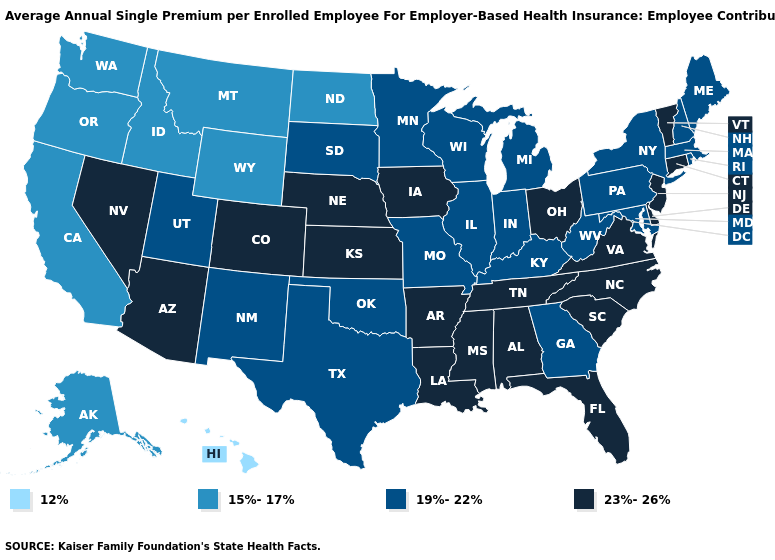Name the states that have a value in the range 19%-22%?
Write a very short answer. Georgia, Illinois, Indiana, Kentucky, Maine, Maryland, Massachusetts, Michigan, Minnesota, Missouri, New Hampshire, New Mexico, New York, Oklahoma, Pennsylvania, Rhode Island, South Dakota, Texas, Utah, West Virginia, Wisconsin. What is the value of Florida?
Write a very short answer. 23%-26%. Which states have the lowest value in the MidWest?
Quick response, please. North Dakota. What is the lowest value in states that border Texas?
Concise answer only. 19%-22%. What is the value of Rhode Island?
Concise answer only. 19%-22%. Which states have the lowest value in the USA?
Write a very short answer. Hawaii. What is the highest value in the West ?
Quick response, please. 23%-26%. Name the states that have a value in the range 19%-22%?
Answer briefly. Georgia, Illinois, Indiana, Kentucky, Maine, Maryland, Massachusetts, Michigan, Minnesota, Missouri, New Hampshire, New Mexico, New York, Oklahoma, Pennsylvania, Rhode Island, South Dakota, Texas, Utah, West Virginia, Wisconsin. What is the value of New Mexico?
Answer briefly. 19%-22%. Does the map have missing data?
Keep it brief. No. Name the states that have a value in the range 19%-22%?
Answer briefly. Georgia, Illinois, Indiana, Kentucky, Maine, Maryland, Massachusetts, Michigan, Minnesota, Missouri, New Hampshire, New Mexico, New York, Oklahoma, Pennsylvania, Rhode Island, South Dakota, Texas, Utah, West Virginia, Wisconsin. Does the first symbol in the legend represent the smallest category?
Concise answer only. Yes. Name the states that have a value in the range 23%-26%?
Short answer required. Alabama, Arizona, Arkansas, Colorado, Connecticut, Delaware, Florida, Iowa, Kansas, Louisiana, Mississippi, Nebraska, Nevada, New Jersey, North Carolina, Ohio, South Carolina, Tennessee, Vermont, Virginia. Which states have the lowest value in the West?
Be succinct. Hawaii. Name the states that have a value in the range 12%?
Quick response, please. Hawaii. 